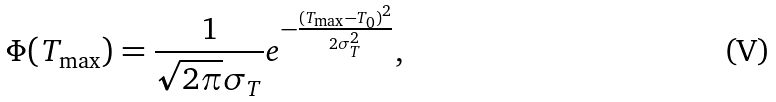<formula> <loc_0><loc_0><loc_500><loc_500>\Phi ( T _ { \max } ) = \frac { 1 } { \sqrt { 2 \pi } \sigma _ { T } } e ^ { - \frac { ( T _ { \max } - T _ { 0 } ) ^ { 2 } } { 2 \sigma _ { T } ^ { 2 } } } ,</formula> 